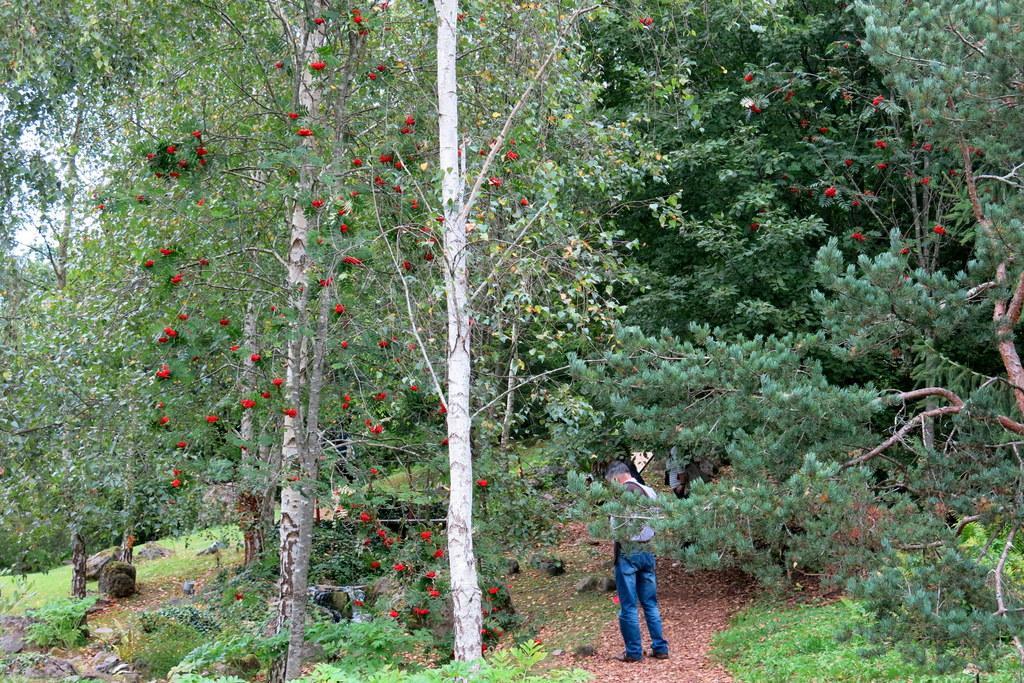Please provide a concise description of this image. In this image there is a person standing, around the person there are trees. 